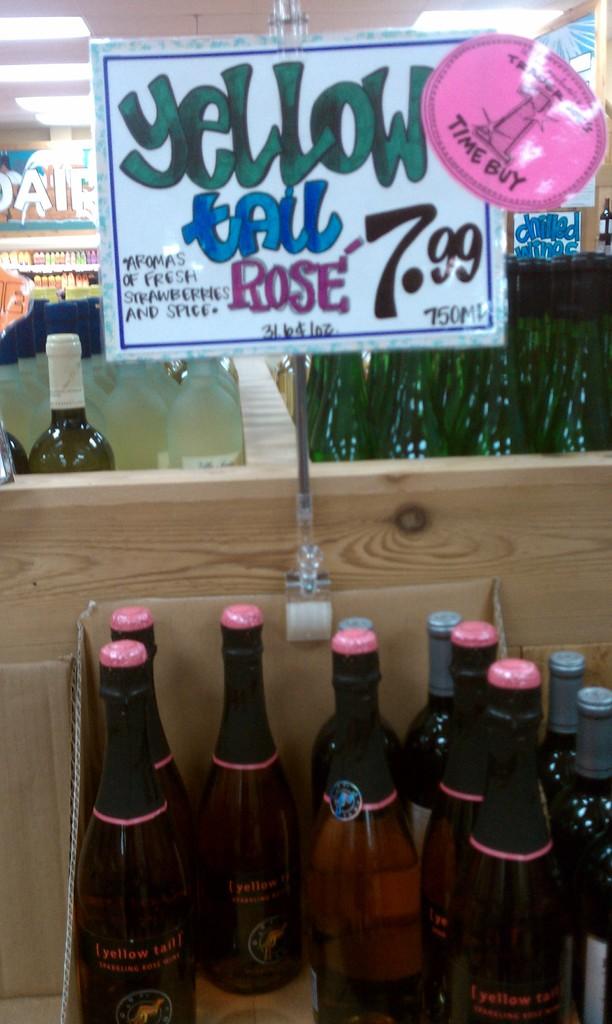How much is it?
Ensure brevity in your answer.  7.99. What costs $7.99?
Your response must be concise. Yellow tail rose. 